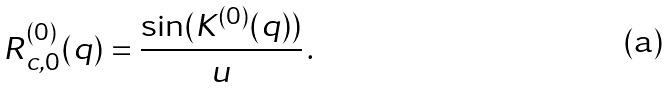<formula> <loc_0><loc_0><loc_500><loc_500>R ^ { ( 0 ) } _ { c , 0 } ( q ) = \frac { \sin ( K ^ { ( 0 ) } ( q ) ) } { u } \, .</formula> 